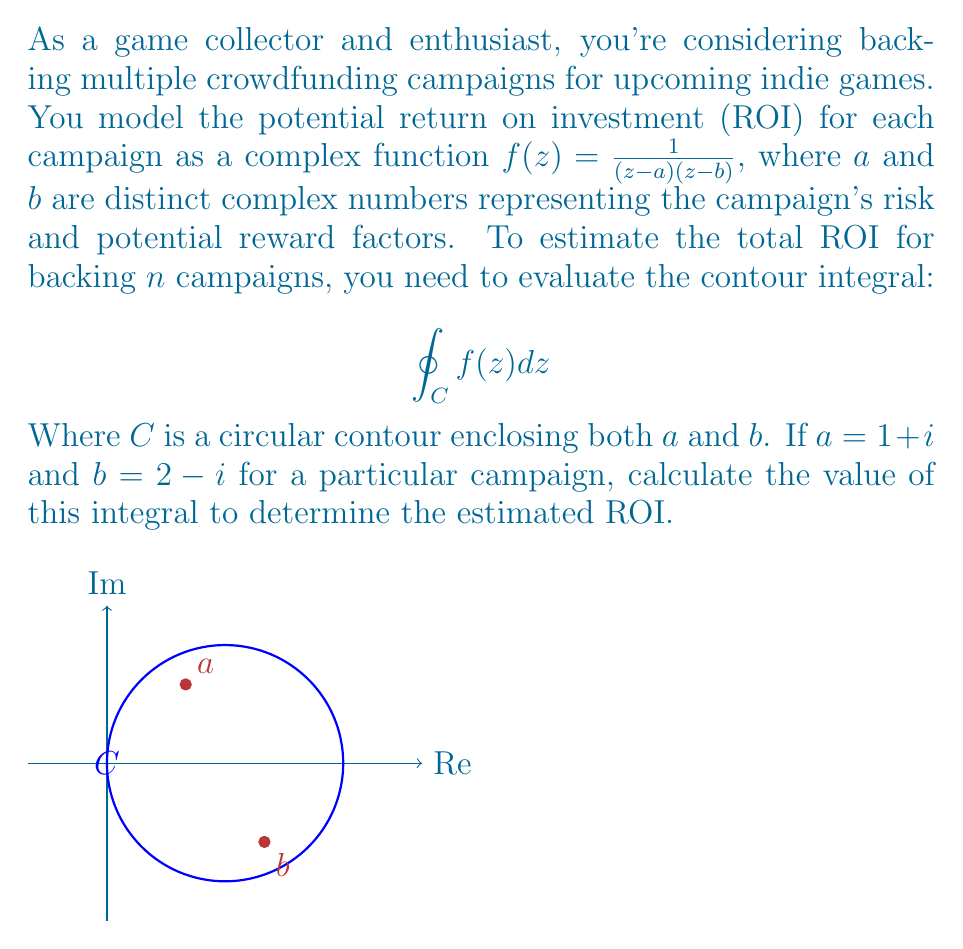Solve this math problem. To solve this problem, we'll use the Residue Theorem from complex analysis. The steps are as follows:

1) The Residue Theorem states that for a function $f(z)$ that is analytic except for isolated singularities inside a simple closed contour $C$:

   $$\oint_C f(z) dz = 2\pi i \sum Res(f,z_k)$$

   where $z_k$ are the singularities inside $C$.

2) In our case, $f(z) = \frac{1}{(z-a)(z-b)}$ has two simple poles at $z=a$ and $z=b$.

3) To find the residues, we use the formula for simple poles:

   $Res(f,z_0) = \lim_{z \to z_0} (z-z_0)f(z)$

4) For $z=a$:
   $$Res(f,a) = \lim_{z \to a} \frac{z-a}{(z-a)(z-b)} = \frac{1}{a-b} = \frac{1}{(1+i)-(2-i)} = \frac{1}{-1+2i} = \frac{-1-2i}{5}$$

5) For $z=b$:
   $$Res(f,b) = \lim_{z \to b} \frac{z-b}{(z-a)(z-b)} = \frac{1}{b-a} = \frac{1}{(2-i)-(1+i)} = \frac{1}{1-2i} = \frac{1+2i}{5}$$

6) Sum the residues and apply the Residue Theorem:

   $$\oint_C f(z) dz = 2\pi i (\frac{-1-2i}{5} + \frac{1+2i}{5}) = 2\pi i (\frac{0}{5}) = 0$$

7) The result indicates that the estimated ROI for this particular campaign is 0, suggesting a neutral investment.

8) For $n$ campaigns, you would repeat this process for each campaign's specific $a$ and $b$ values and sum the results.
Answer: $0$ 